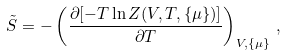<formula> <loc_0><loc_0><loc_500><loc_500>\tilde { S } = - \left ( \frac { \partial [ - T \ln Z ( V , T , \{ \mu \} ) ] } { \partial T } \right ) _ { V , \{ \mu \} } \, ,</formula> 